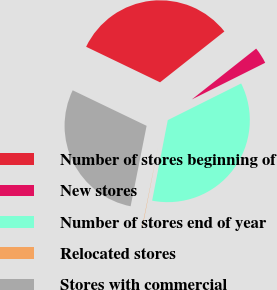<chart> <loc_0><loc_0><loc_500><loc_500><pie_chart><fcel>Number of stores beginning of<fcel>New stores<fcel>Number of stores end of year<fcel>Relocated stores<fcel>Stores with commercial<nl><fcel>32.22%<fcel>3.27%<fcel>35.43%<fcel>0.07%<fcel>29.01%<nl></chart> 